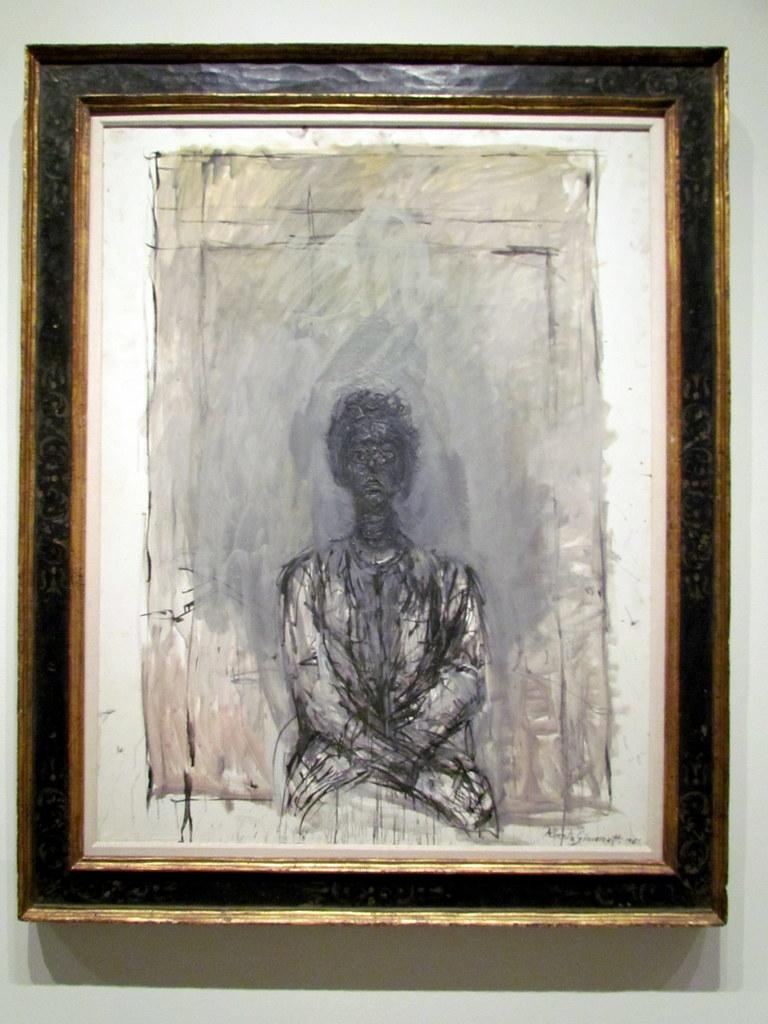What object is present in the image that typically holds a picture or artwork? There is a photo frame in the image. What is depicted inside the photo frame? The photo frame contains a drawing of a person. On what surface is the photo frame placed? The photo frame is on a white color surface. How does the person in the drawing feel about the cold winter season? The image does not provide any information about the person's feelings or the winter season, as it only shows a drawing of a person inside a photo frame. 